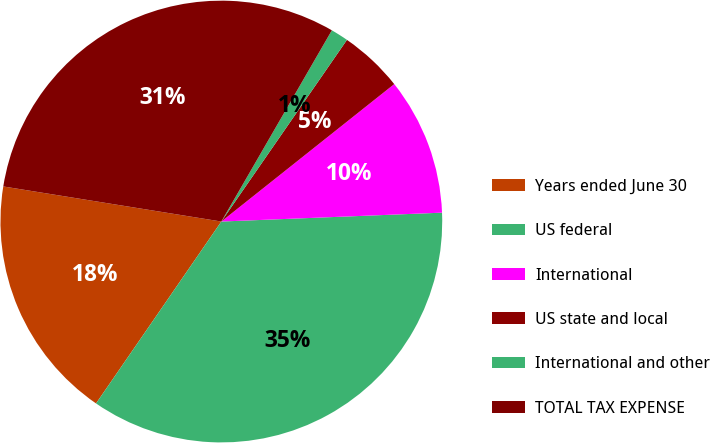Convert chart to OTSL. <chart><loc_0><loc_0><loc_500><loc_500><pie_chart><fcel>Years ended June 30<fcel>US federal<fcel>International<fcel>US state and local<fcel>International and other<fcel>TOTAL TAX EXPENSE<nl><fcel>17.94%<fcel>35.24%<fcel>10.05%<fcel>4.68%<fcel>1.29%<fcel>30.8%<nl></chart> 